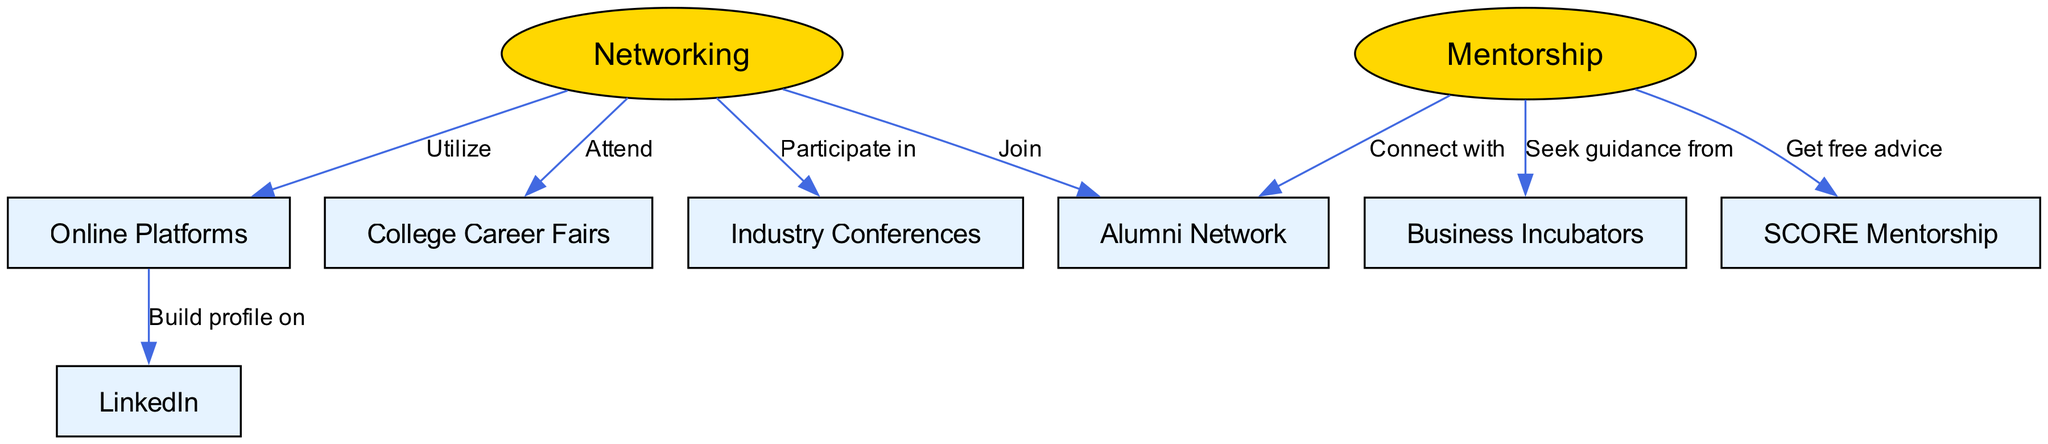What are the two main categories featured in the diagram? The diagram features two main categories, which are explicitly labeled as "Networking" and "Mentorship." They are visually distinguished as different node types—one as an ellipse and the other as a rectangle.
Answer: Networking, Mentorship How many edges connect to the "Networking" node? By examining the edges branching from the "Networking" node, we see that there are four connections: to "College Career Fairs," "Alumni Network," "Industry Conferences," and "Online Platforms." Therefore, there are four edges.
Answer: 4 Which event type is directly linked to the "Mentorship" node? The "Mentorship" node has three distinct edges, but one of these edges connects directly to "Alumni Network," indicating a direct relationship.
Answer: Alumni Network What online platform is mentioned in the diagram? The diagram mentions "LinkedIn" as an online platform related to networking. This is derived from the edge connecting "Online Platforms" to "LinkedIn."
Answer: LinkedIn If one seeks guidance, which resource should they connect to according to the diagram? According to the diagram, if someone seeks guidance, they should connect with "Business Incubators," as indicated by the edge linking "Mentorship" to "Incubators."
Answer: Business Incubators How many nodes are related to mentorship opportunities? Looking at the nodes that are specifically connected to mentorship, we can identify three: "Alumni Network," "Business Incubators," and "SCORE Mentorship." Hence, the total is three.
Answer: 3 What is the action linked between "Networking" and "Industry Conferences"? The action linked between "Networking" and "Industry Conferences" is "Participate in," which is the specific relationship indicated by the edge connecting these two nodes in the diagram.
Answer: Participate in Which mentorship service provides free advice? The "SCORE Mentorship" service is identified in the diagram as providing free advice through a direct relationship with the "Mentorship" node.
Answer: SCORE Mentorship 